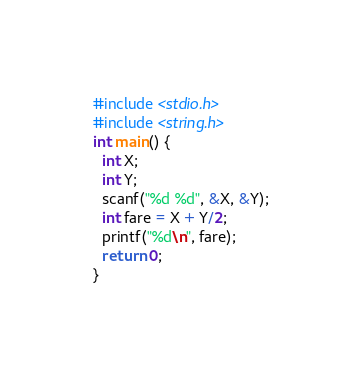<code> <loc_0><loc_0><loc_500><loc_500><_C_>#include <stdio.h>
#include <string.h>
int main() {
  int X;
  int Y;
  scanf("%d %d", &X, &Y);
  int fare = X + Y/2;
  printf("%d\n", fare);
  return 0;
}</code> 